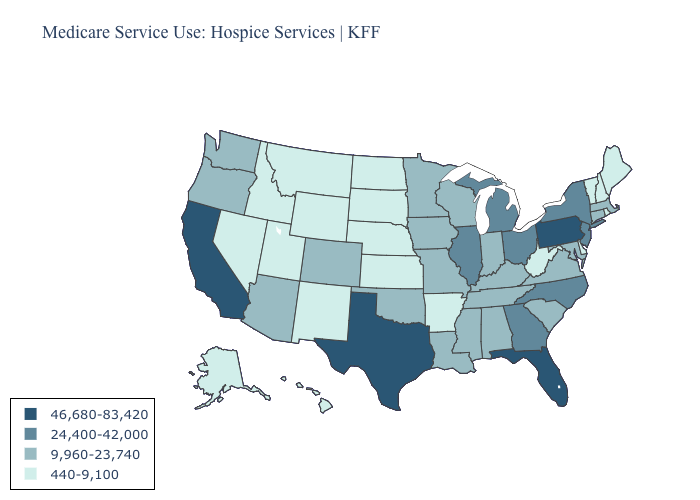Does Vermont have the highest value in the USA?
Write a very short answer. No. What is the value of Mississippi?
Quick response, please. 9,960-23,740. Does New Mexico have the lowest value in the USA?
Give a very brief answer. Yes. Does California have the highest value in the USA?
Quick response, please. Yes. Does the first symbol in the legend represent the smallest category?
Answer briefly. No. What is the value of Iowa?
Concise answer only. 9,960-23,740. What is the lowest value in the USA?
Short answer required. 440-9,100. Does Louisiana have a lower value than Alabama?
Be succinct. No. What is the highest value in the USA?
Concise answer only. 46,680-83,420. Name the states that have a value in the range 24,400-42,000?
Write a very short answer. Georgia, Illinois, Michigan, New Jersey, New York, North Carolina, Ohio. Among the states that border North Dakota , does Montana have the lowest value?
Answer briefly. Yes. Which states have the lowest value in the USA?
Concise answer only. Alaska, Arkansas, Delaware, Hawaii, Idaho, Kansas, Maine, Montana, Nebraska, Nevada, New Hampshire, New Mexico, North Dakota, Rhode Island, South Dakota, Utah, Vermont, West Virginia, Wyoming. What is the lowest value in the West?
Be succinct. 440-9,100. Name the states that have a value in the range 24,400-42,000?
Quick response, please. Georgia, Illinois, Michigan, New Jersey, New York, North Carolina, Ohio. What is the value of Kentucky?
Concise answer only. 9,960-23,740. 